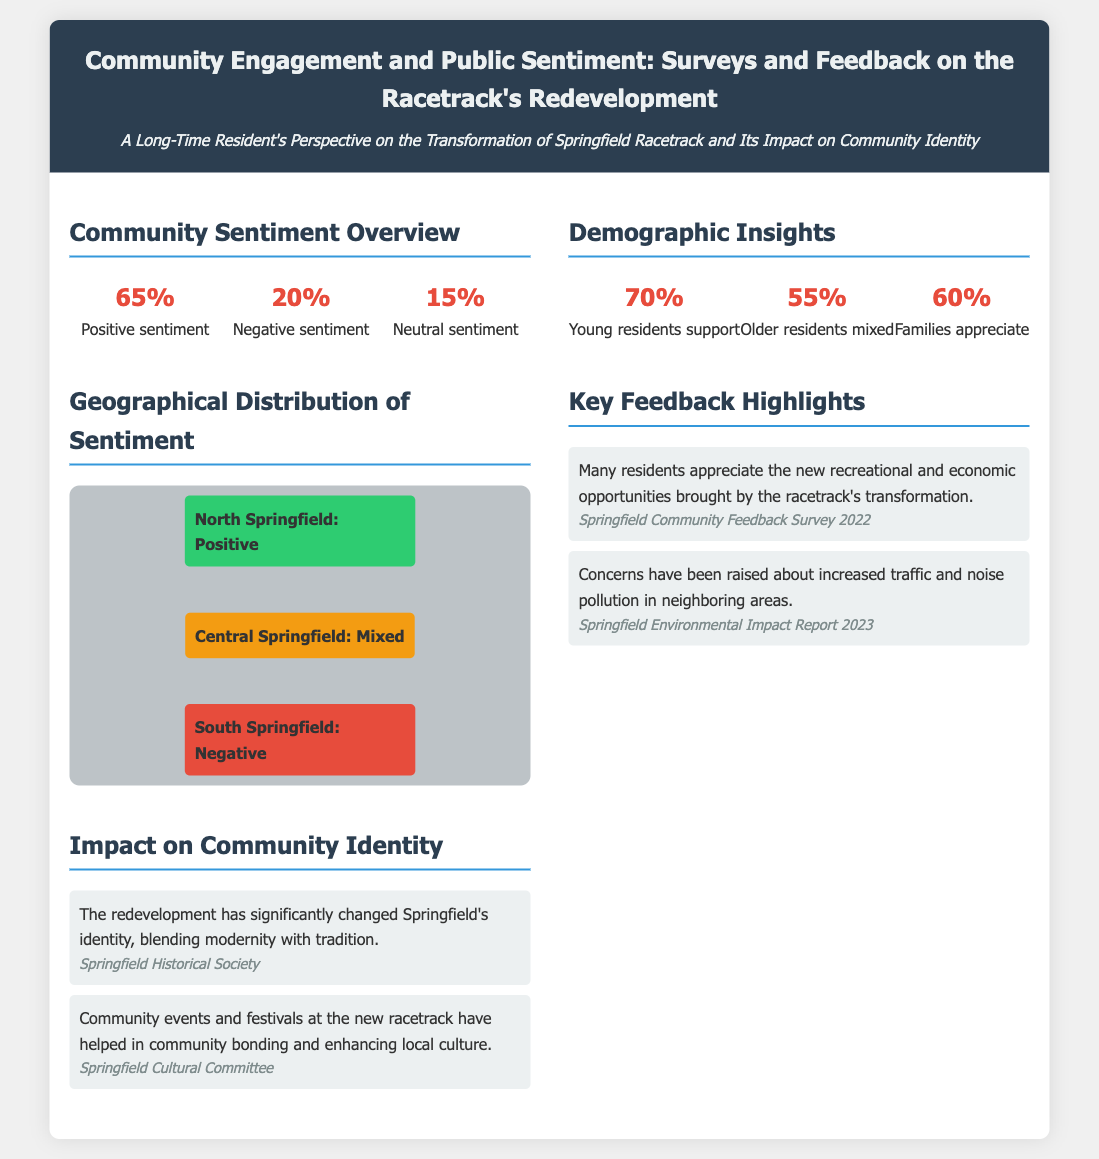What percentage of residents have a positive sentiment? The document states that 65% of residents have a positive sentiment towards the racetrack redevelopment.
Answer: 65% What is the sentiment percentage for negative feedback? According to the infographic, 20% of respondents reported negative sentiment regarding the redevelopment.
Answer: 20% What demographic has the highest support for the racetrack? The infographic indicates that 70% of young residents support the racetrack's redevelopment.
Answer: Young residents Which area of Springfield has a mixed sentiment? The document highlights Central Springfield as having a mixed sentiment regarding the racetrack redevelopment.
Answer: Central Springfield What were some concerns raised by residents? The infographic lists increased traffic and noise pollution as concerns raised by residents in the feedback.
Answer: Increased traffic and noise pollution Which group appreciates the changes made to the racetrack? The document mentions that families particularly appreciate the recreational opportunities brought by the redevelopment.
Answer: Families What is the source of the feedback regarding community events? The source mentioned for feedback about community events and festivals is the Springfield Cultural Committee.
Answer: Springfield Cultural Committee What aspect did the redevelopment significantly change? The redevelopment significantly changed Springfield's identity, blending modernity with tradition.
Answer: Community identity What percentage of older residents expressed mixed feelings? The document states that 55% of older residents have mixed sentiments about the racetrack redevelopment.
Answer: 55% 